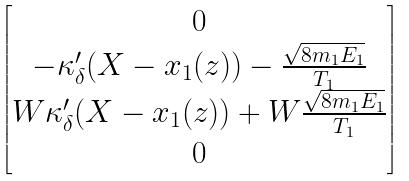Convert formula to latex. <formula><loc_0><loc_0><loc_500><loc_500>\begin{bmatrix} 0 \\ - \kappa _ { \delta } ^ { \prime } ( X - x _ { 1 } ( z ) ) - \frac { \sqrt { 8 m _ { 1 } E _ { 1 } } } { T _ { 1 } } \\ W \kappa _ { \delta } ^ { \prime } ( X - x _ { 1 } ( z ) ) + W \frac { \sqrt { 8 m _ { 1 } E _ { 1 } } } { T _ { 1 } } \\ 0 \\ \end{bmatrix}</formula> 